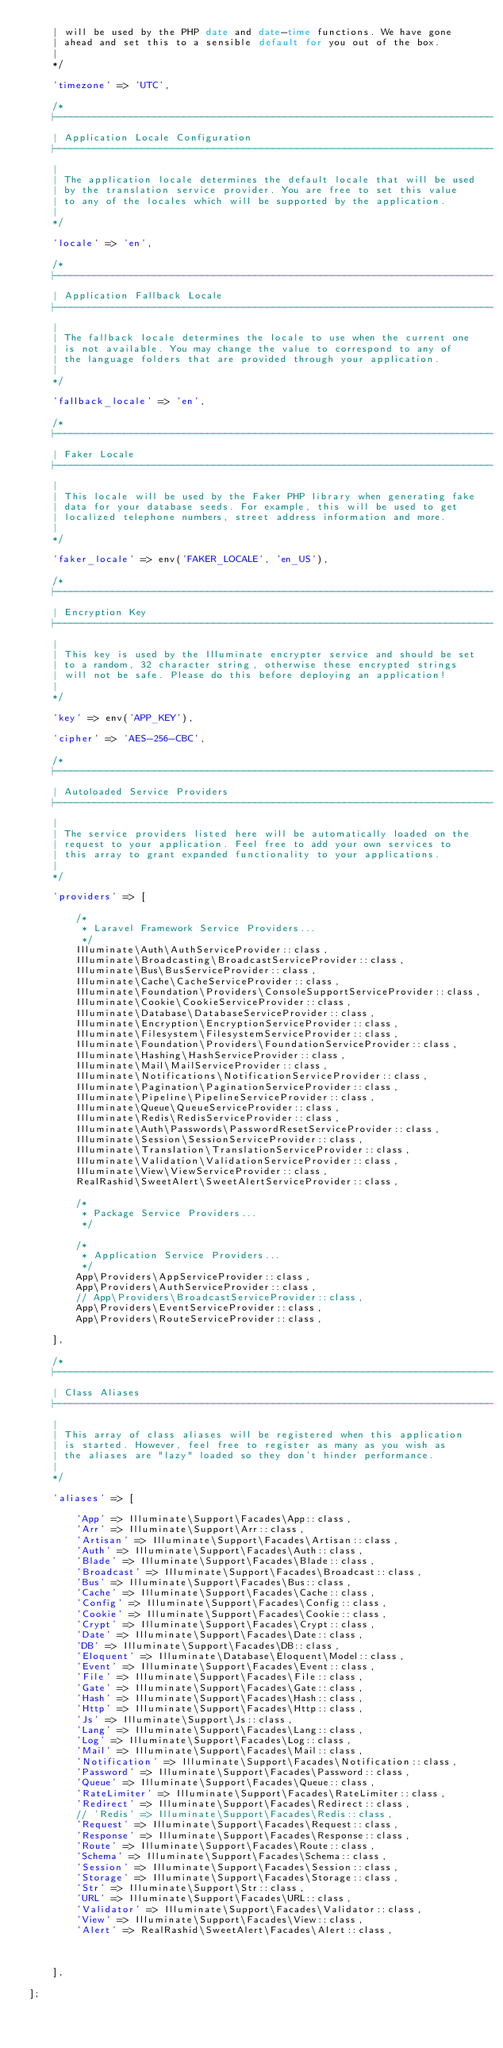<code> <loc_0><loc_0><loc_500><loc_500><_PHP_>    | will be used by the PHP date and date-time functions. We have gone
    | ahead and set this to a sensible default for you out of the box.
    |
    */

    'timezone' => 'UTC',

    /*
    |--------------------------------------------------------------------------
    | Application Locale Configuration
    |--------------------------------------------------------------------------
    |
    | The application locale determines the default locale that will be used
    | by the translation service provider. You are free to set this value
    | to any of the locales which will be supported by the application.
    |
    */

    'locale' => 'en',

    /*
    |--------------------------------------------------------------------------
    | Application Fallback Locale
    |--------------------------------------------------------------------------
    |
    | The fallback locale determines the locale to use when the current one
    | is not available. You may change the value to correspond to any of
    | the language folders that are provided through your application.
    |
    */

    'fallback_locale' => 'en',

    /*
    |--------------------------------------------------------------------------
    | Faker Locale
    |--------------------------------------------------------------------------
    |
    | This locale will be used by the Faker PHP library when generating fake
    | data for your database seeds. For example, this will be used to get
    | localized telephone numbers, street address information and more.
    |
    */

    'faker_locale' => env('FAKER_LOCALE', 'en_US'),

    /*
    |--------------------------------------------------------------------------
    | Encryption Key
    |--------------------------------------------------------------------------
    |
    | This key is used by the Illuminate encrypter service and should be set
    | to a random, 32 character string, otherwise these encrypted strings
    | will not be safe. Please do this before deploying an application!
    |
    */

    'key' => env('APP_KEY'),

    'cipher' => 'AES-256-CBC',

    /*
    |--------------------------------------------------------------------------
    | Autoloaded Service Providers
    |--------------------------------------------------------------------------
    |
    | The service providers listed here will be automatically loaded on the
    | request to your application. Feel free to add your own services to
    | this array to grant expanded functionality to your applications.
    |
    */

    'providers' => [

        /*
         * Laravel Framework Service Providers...
         */
        Illuminate\Auth\AuthServiceProvider::class,
        Illuminate\Broadcasting\BroadcastServiceProvider::class,
        Illuminate\Bus\BusServiceProvider::class,
        Illuminate\Cache\CacheServiceProvider::class,
        Illuminate\Foundation\Providers\ConsoleSupportServiceProvider::class,
        Illuminate\Cookie\CookieServiceProvider::class,
        Illuminate\Database\DatabaseServiceProvider::class,
        Illuminate\Encryption\EncryptionServiceProvider::class,
        Illuminate\Filesystem\FilesystemServiceProvider::class,
        Illuminate\Foundation\Providers\FoundationServiceProvider::class,
        Illuminate\Hashing\HashServiceProvider::class,
        Illuminate\Mail\MailServiceProvider::class,
        Illuminate\Notifications\NotificationServiceProvider::class,
        Illuminate\Pagination\PaginationServiceProvider::class,
        Illuminate\Pipeline\PipelineServiceProvider::class,
        Illuminate\Queue\QueueServiceProvider::class,
        Illuminate\Redis\RedisServiceProvider::class,
        Illuminate\Auth\Passwords\PasswordResetServiceProvider::class,
        Illuminate\Session\SessionServiceProvider::class,
        Illuminate\Translation\TranslationServiceProvider::class,
        Illuminate\Validation\ValidationServiceProvider::class,
        Illuminate\View\ViewServiceProvider::class,
        RealRashid\SweetAlert\SweetAlertServiceProvider::class,

        /*
         * Package Service Providers...
         */

        /*
         * Application Service Providers...
         */
        App\Providers\AppServiceProvider::class,
        App\Providers\AuthServiceProvider::class,
        // App\Providers\BroadcastServiceProvider::class,
        App\Providers\EventServiceProvider::class,
        App\Providers\RouteServiceProvider::class,

    ],

    /*
    |--------------------------------------------------------------------------
    | Class Aliases
    |--------------------------------------------------------------------------
    |
    | This array of class aliases will be registered when this application
    | is started. However, feel free to register as many as you wish as
    | the aliases are "lazy" loaded so they don't hinder performance.
    |
    */

    'aliases' => [

        'App' => Illuminate\Support\Facades\App::class,
        'Arr' => Illuminate\Support\Arr::class,
        'Artisan' => Illuminate\Support\Facades\Artisan::class,
        'Auth' => Illuminate\Support\Facades\Auth::class,
        'Blade' => Illuminate\Support\Facades\Blade::class,
        'Broadcast' => Illuminate\Support\Facades\Broadcast::class,
        'Bus' => Illuminate\Support\Facades\Bus::class,
        'Cache' => Illuminate\Support\Facades\Cache::class,
        'Config' => Illuminate\Support\Facades\Config::class,
        'Cookie' => Illuminate\Support\Facades\Cookie::class,
        'Crypt' => Illuminate\Support\Facades\Crypt::class,
        'Date' => Illuminate\Support\Facades\Date::class,
        'DB' => Illuminate\Support\Facades\DB::class,
        'Eloquent' => Illuminate\Database\Eloquent\Model::class,
        'Event' => Illuminate\Support\Facades\Event::class,
        'File' => Illuminate\Support\Facades\File::class,
        'Gate' => Illuminate\Support\Facades\Gate::class,
        'Hash' => Illuminate\Support\Facades\Hash::class,
        'Http' => Illuminate\Support\Facades\Http::class,
        'Js' => Illuminate\Support\Js::class,
        'Lang' => Illuminate\Support\Facades\Lang::class,
        'Log' => Illuminate\Support\Facades\Log::class,
        'Mail' => Illuminate\Support\Facades\Mail::class,
        'Notification' => Illuminate\Support\Facades\Notification::class,
        'Password' => Illuminate\Support\Facades\Password::class,
        'Queue' => Illuminate\Support\Facades\Queue::class,
        'RateLimiter' => Illuminate\Support\Facades\RateLimiter::class,
        'Redirect' => Illuminate\Support\Facades\Redirect::class,
        // 'Redis' => Illuminate\Support\Facades\Redis::class,
        'Request' => Illuminate\Support\Facades\Request::class,
        'Response' => Illuminate\Support\Facades\Response::class,
        'Route' => Illuminate\Support\Facades\Route::class,
        'Schema' => Illuminate\Support\Facades\Schema::class,
        'Session' => Illuminate\Support\Facades\Session::class,
        'Storage' => Illuminate\Support\Facades\Storage::class,
        'Str' => Illuminate\Support\Str::class,
        'URL' => Illuminate\Support\Facades\URL::class,
        'Validator' => Illuminate\Support\Facades\Validator::class,
        'View' => Illuminate\Support\Facades\View::class,
        'Alert' => RealRashid\SweetAlert\Facades\Alert::class,



    ],

];
</code> 